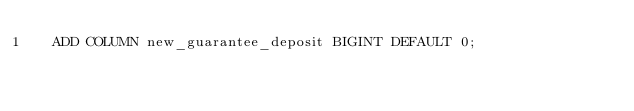Convert code to text. <code><loc_0><loc_0><loc_500><loc_500><_SQL_>  ADD COLUMN new_guarantee_deposit BIGINT DEFAULT 0;

</code> 